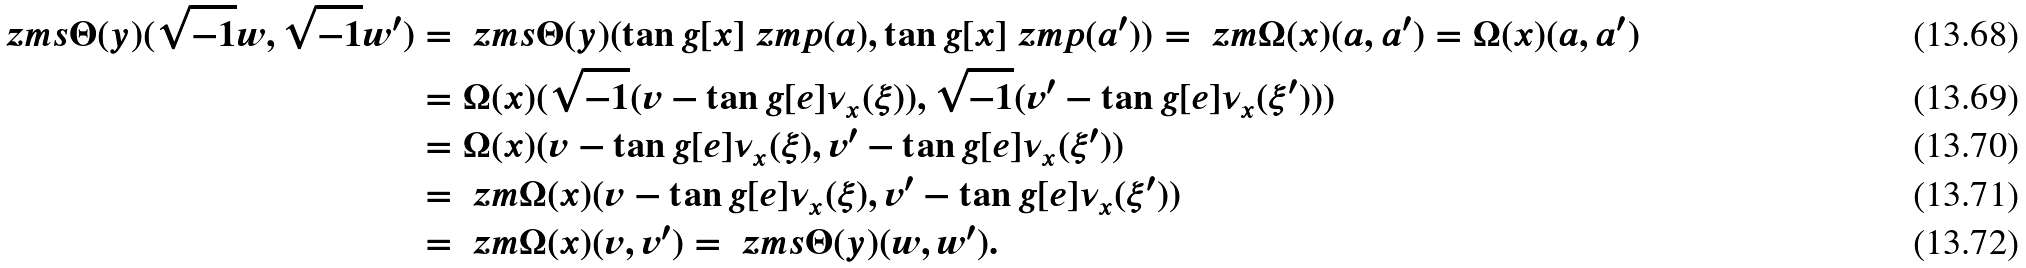<formula> <loc_0><loc_0><loc_500><loc_500>\ z m s { \Theta } ( y ) ( \sqrt { - 1 } w , \sqrt { - 1 } w ^ { \prime } ) & = \ z m s { \Theta } ( y ) ( \tan g [ x ] { \ z m { p } } ( a ) , \tan g [ x ] { \ z m { p } } ( a ^ { \prime } ) ) = \ z m { \Omega } ( x ) ( a , a ^ { \prime } ) = \Omega ( x ) ( a , a ^ { \prime } ) \\ & = \Omega ( x ) ( \sqrt { - 1 } ( v - \tan g [ e ] { \nu _ { x } } ( \xi ) ) , \sqrt { - 1 } ( v ^ { \prime } - \tan g [ e ] { \nu _ { x } } ( \xi ^ { \prime } ) ) ) \\ & = \Omega ( x ) ( v - \tan g [ e ] { \nu _ { x } } ( \xi ) , v ^ { \prime } - \tan g [ e ] { \nu _ { x } } ( \xi ^ { \prime } ) ) \\ & = \ z m { \Omega } ( x ) ( v - \tan g [ e ] { \nu _ { x } } ( \xi ) , v ^ { \prime } - \tan g [ e ] { \nu _ { x } } ( \xi ^ { \prime } ) ) \\ & = \ z m { \Omega } ( x ) ( v , v ^ { \prime } ) = \ z m s { \Theta } ( y ) ( w , w ^ { \prime } ) .</formula> 